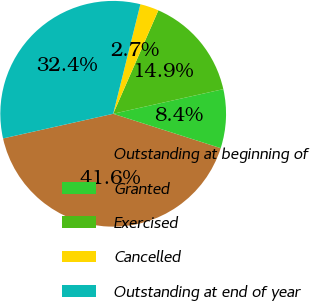Convert chart to OTSL. <chart><loc_0><loc_0><loc_500><loc_500><pie_chart><fcel>Outstanding at beginning of<fcel>Granted<fcel>Exercised<fcel>Cancelled<fcel>Outstanding at end of year<nl><fcel>41.57%<fcel>8.43%<fcel>14.94%<fcel>2.68%<fcel>32.38%<nl></chart> 